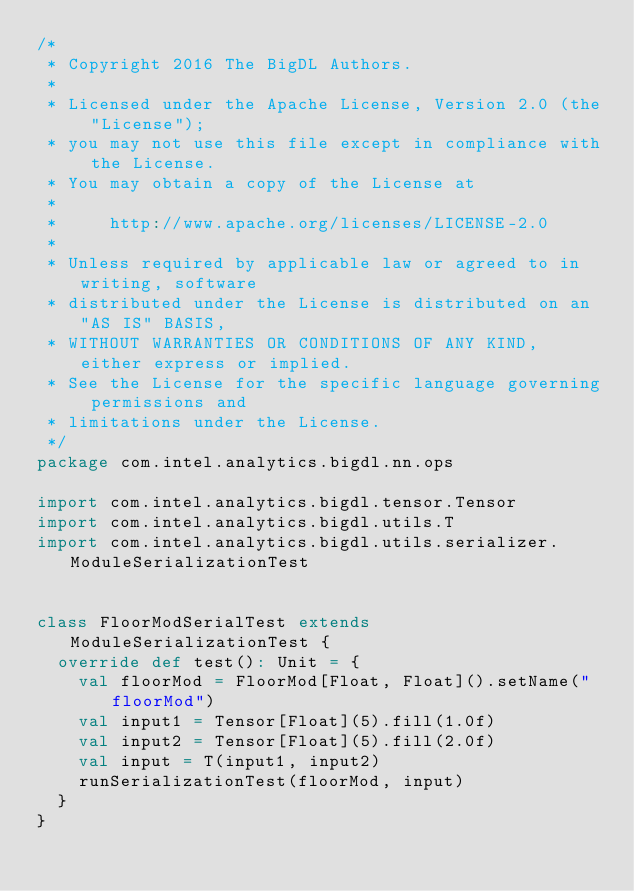Convert code to text. <code><loc_0><loc_0><loc_500><loc_500><_Scala_>/*
 * Copyright 2016 The BigDL Authors.
 *
 * Licensed under the Apache License, Version 2.0 (the "License");
 * you may not use this file except in compliance with the License.
 * You may obtain a copy of the License at
 *
 *     http://www.apache.org/licenses/LICENSE-2.0
 *
 * Unless required by applicable law or agreed to in writing, software
 * distributed under the License is distributed on an "AS IS" BASIS,
 * WITHOUT WARRANTIES OR CONDITIONS OF ANY KIND, either express or implied.
 * See the License for the specific language governing permissions and
 * limitations under the License.
 */
package com.intel.analytics.bigdl.nn.ops

import com.intel.analytics.bigdl.tensor.Tensor
import com.intel.analytics.bigdl.utils.T
import com.intel.analytics.bigdl.utils.serializer.ModuleSerializationTest


class FloorModSerialTest extends ModuleSerializationTest {
  override def test(): Unit = {
    val floorMod = FloorMod[Float, Float]().setName("floorMod")
    val input1 = Tensor[Float](5).fill(1.0f)
    val input2 = Tensor[Float](5).fill(2.0f)
    val input = T(input1, input2)
    runSerializationTest(floorMod, input)
  }
}
</code> 